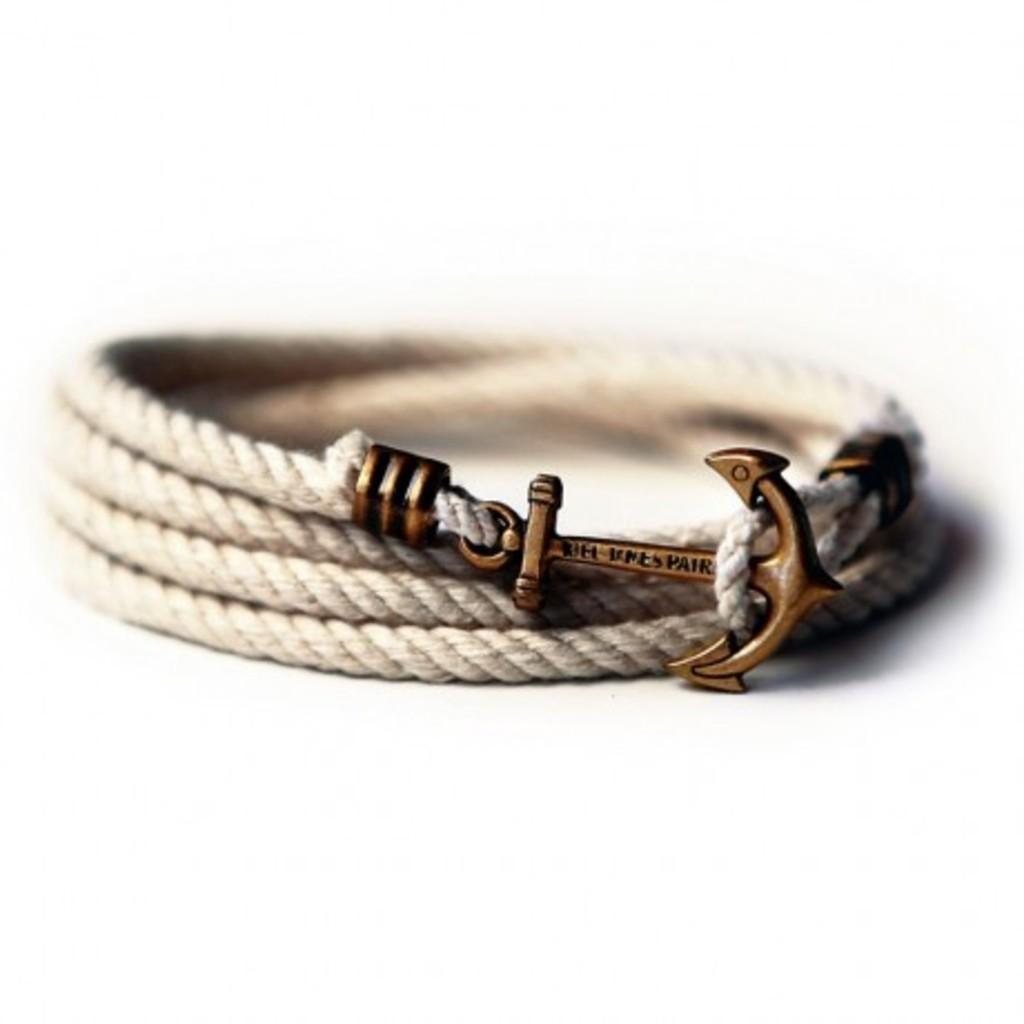Please provide a concise description of this image. In this image we can see a bracelet. 